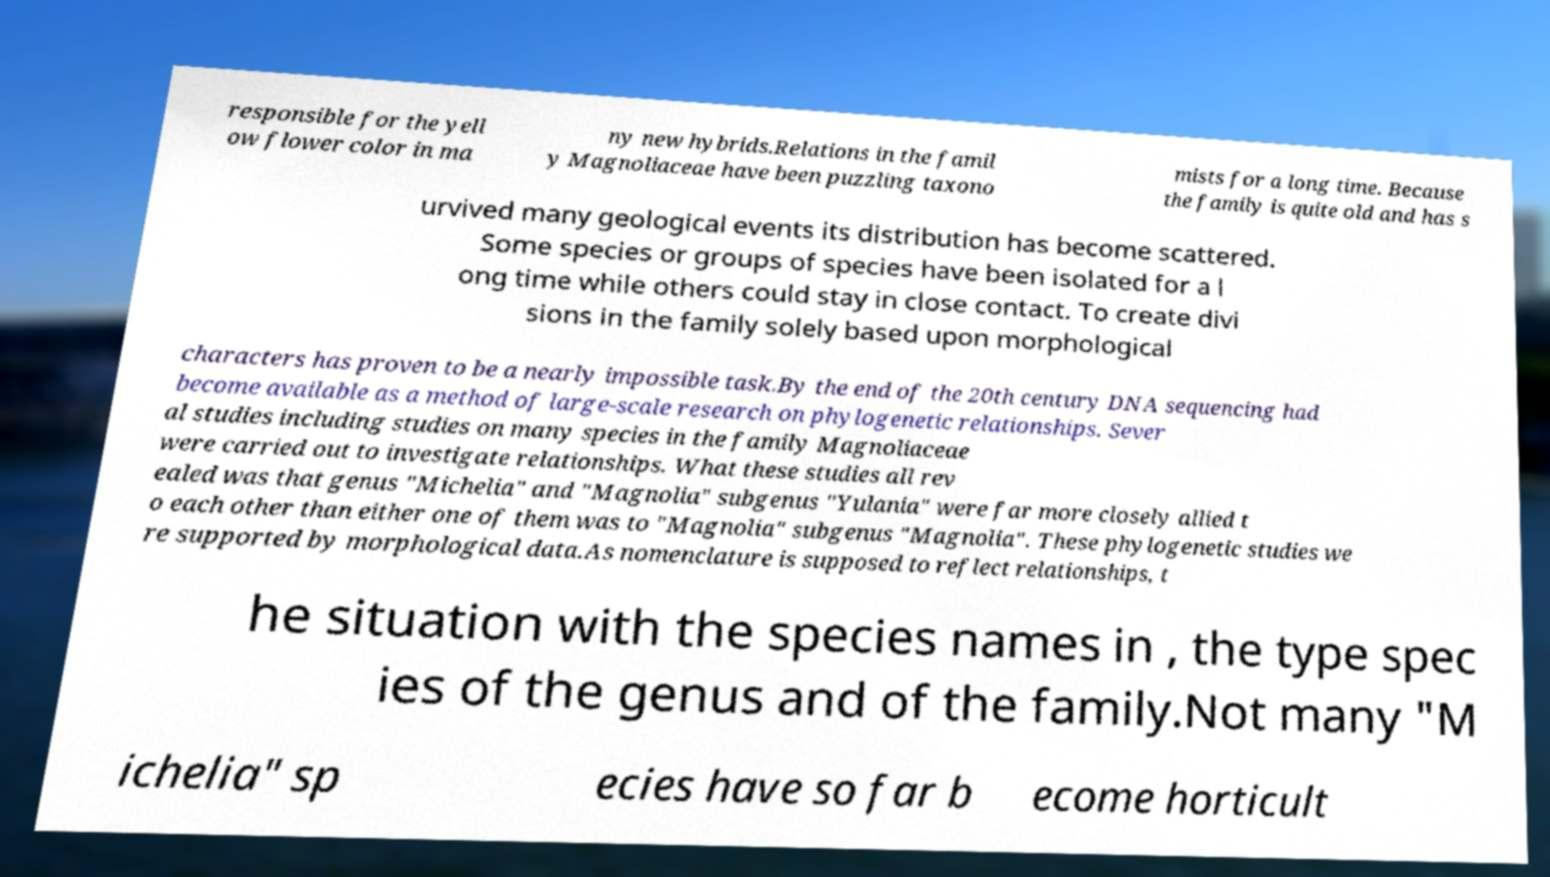What messages or text are displayed in this image? I need them in a readable, typed format. responsible for the yell ow flower color in ma ny new hybrids.Relations in the famil y Magnoliaceae have been puzzling taxono mists for a long time. Because the family is quite old and has s urvived many geological events its distribution has become scattered. Some species or groups of species have been isolated for a l ong time while others could stay in close contact. To create divi sions in the family solely based upon morphological characters has proven to be a nearly impossible task.By the end of the 20th century DNA sequencing had become available as a method of large-scale research on phylogenetic relationships. Sever al studies including studies on many species in the family Magnoliaceae were carried out to investigate relationships. What these studies all rev ealed was that genus "Michelia" and "Magnolia" subgenus "Yulania" were far more closely allied t o each other than either one of them was to "Magnolia" subgenus "Magnolia". These phylogenetic studies we re supported by morphological data.As nomenclature is supposed to reflect relationships, t he situation with the species names in , the type spec ies of the genus and of the family.Not many "M ichelia" sp ecies have so far b ecome horticult 